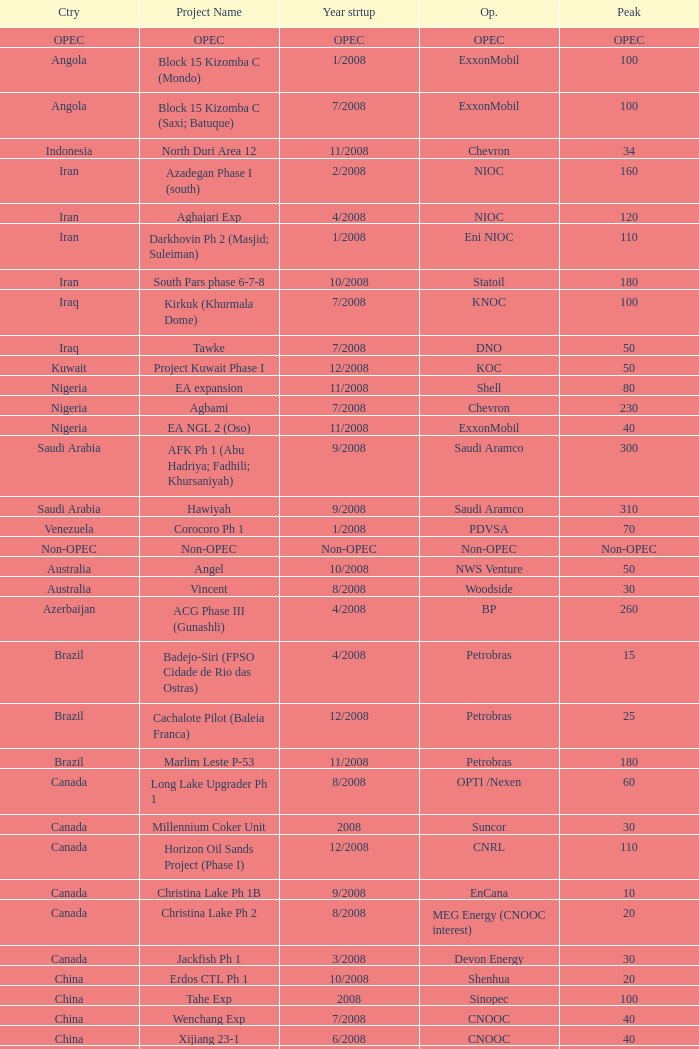What is the Peak with a Project Name that is talakan ph 1? 60.0. Write the full table. {'header': ['Ctry', 'Project Name', 'Year strtup', 'Op.', 'Peak'], 'rows': [['OPEC', 'OPEC', 'OPEC', 'OPEC', 'OPEC'], ['Angola', 'Block 15 Kizomba C (Mondo)', '1/2008', 'ExxonMobil', '100'], ['Angola', 'Block 15 Kizomba C (Saxi; Batuque)', '7/2008', 'ExxonMobil', '100'], ['Indonesia', 'North Duri Area 12', '11/2008', 'Chevron', '34'], ['Iran', 'Azadegan Phase I (south)', '2/2008', 'NIOC', '160'], ['Iran', 'Aghajari Exp', '4/2008', 'NIOC', '120'], ['Iran', 'Darkhovin Ph 2 (Masjid; Suleiman)', '1/2008', 'Eni NIOC', '110'], ['Iran', 'South Pars phase 6-7-8', '10/2008', 'Statoil', '180'], ['Iraq', 'Kirkuk (Khurmala Dome)', '7/2008', 'KNOC', '100'], ['Iraq', 'Tawke', '7/2008', 'DNO', '50'], ['Kuwait', 'Project Kuwait Phase I', '12/2008', 'KOC', '50'], ['Nigeria', 'EA expansion', '11/2008', 'Shell', '80'], ['Nigeria', 'Agbami', '7/2008', 'Chevron', '230'], ['Nigeria', 'EA NGL 2 (Oso)', '11/2008', 'ExxonMobil', '40'], ['Saudi Arabia', 'AFK Ph 1 (Abu Hadriya; Fadhili; Khursaniyah)', '9/2008', 'Saudi Aramco', '300'], ['Saudi Arabia', 'Hawiyah', '9/2008', 'Saudi Aramco', '310'], ['Venezuela', 'Corocoro Ph 1', '1/2008', 'PDVSA', '70'], ['Non-OPEC', 'Non-OPEC', 'Non-OPEC', 'Non-OPEC', 'Non-OPEC'], ['Australia', 'Angel', '10/2008', 'NWS Venture', '50'], ['Australia', 'Vincent', '8/2008', 'Woodside', '30'], ['Azerbaijan', 'ACG Phase III (Gunashli)', '4/2008', 'BP', '260'], ['Brazil', 'Badejo-Siri (FPSO Cidade de Rio das Ostras)', '4/2008', 'Petrobras', '15'], ['Brazil', 'Cachalote Pilot (Baleia Franca)', '12/2008', 'Petrobras', '25'], ['Brazil', 'Marlim Leste P-53', '11/2008', 'Petrobras', '180'], ['Canada', 'Long Lake Upgrader Ph 1', '8/2008', 'OPTI /Nexen', '60'], ['Canada', 'Millennium Coker Unit', '2008', 'Suncor', '30'], ['Canada', 'Horizon Oil Sands Project (Phase I)', '12/2008', 'CNRL', '110'], ['Canada', 'Christina Lake Ph 1B', '9/2008', 'EnCana', '10'], ['Canada', 'Christina Lake Ph 2', '8/2008', 'MEG Energy (CNOOC interest)', '20'], ['Canada', 'Jackfish Ph 1', '3/2008', 'Devon Energy', '30'], ['China', 'Erdos CTL Ph 1', '10/2008', 'Shenhua', '20'], ['China', 'Tahe Exp', '2008', 'Sinopec', '100'], ['China', 'Wenchang Exp', '7/2008', 'CNOOC', '40'], ['China', 'Xijiang 23-1', '6/2008', 'CNOOC', '40'], ['Congo', 'Moho Bilondo', '4/2008', 'Total', '90'], ['Egypt', 'Saqqara', '3/2008', 'BP', '40'], ['India', 'MA field (KG-D6)', '9/2008', 'Reliance', '40'], ['Kazakhstan', 'Dunga', '3/2008', 'Maersk', '150'], ['Kazakhstan', 'Komsomolskoe', '5/2008', 'Petrom', '10'], ['Mexico', '( Chicontepec ) Exp 1', '2008', 'PEMEX', '200'], ['Mexico', 'Antonio J Bermudez Exp', '5/2008', 'PEMEX', '20'], ['Mexico', 'Bellota Chinchorro Exp', '5/2008', 'PEMEX', '20'], ['Mexico', 'Ixtal Manik', '2008', 'PEMEX', '55'], ['Mexico', 'Jujo Tecominoacan Exp', '2008', 'PEMEX', '15'], ['Norway', 'Alvheim; Volund; Vilje', '6/2008', 'Marathon', '100'], ['Norway', 'Volve', '2/2008', 'StatoilHydro', '35'], ['Oman', 'Mukhaizna EOR Ph 1', '2008', 'Occidental', '40'], ['Philippines', 'Galoc', '10/2008', 'GPC', '15'], ['Russia', 'Talakan Ph 1', '10/2008', 'Surgutneftegaz', '60'], ['Russia', 'Verkhnechonsk Ph 1 (early oil)', '10/2008', 'TNK-BP Rosneft', '20'], ['Russia', 'Yuzhno-Khylchuyuskoye "YK" Ph 1', '8/2008', 'Lukoil ConocoPhillips', '75'], ['Thailand', 'Bualuang', '8/2008', 'Salamander', '10'], ['UK', 'Britannia Satellites (Callanish; Brodgar)', '7/2008', 'Conoco Phillips', '25'], ['USA', 'Blind Faith', '11/2008', 'Chevron', '45'], ['USA', 'Neptune', '7/2008', 'BHP Billiton', '25'], ['USA', 'Oooguruk', '6/2008', 'Pioneer', '15'], ['USA', 'Qannik', '7/2008', 'ConocoPhillips', '4'], ['USA', 'Thunder Horse', '6/2008', 'BP', '210'], ['USA', 'Ursa Princess Exp', '1/2008', 'Shell', '30'], ['Vietnam', 'Ca Ngu Vang (Golden Tuna)', '7/2008', 'HVJOC', '15'], ['Vietnam', 'Su Tu Vang', '10/2008', 'Cuu Long Joint', '40'], ['Vietnam', 'Song Doc', '12/2008', 'Talisman', '10']]} 